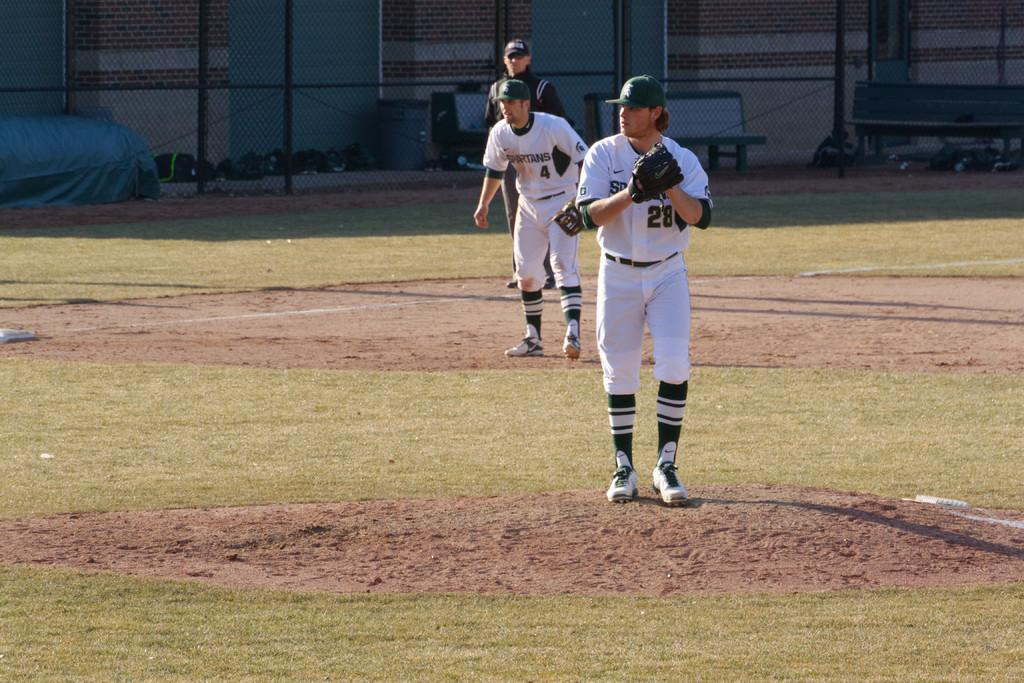<image>
Provide a brief description of the given image. Player number 28 about to pitch as number 4 watches on. 